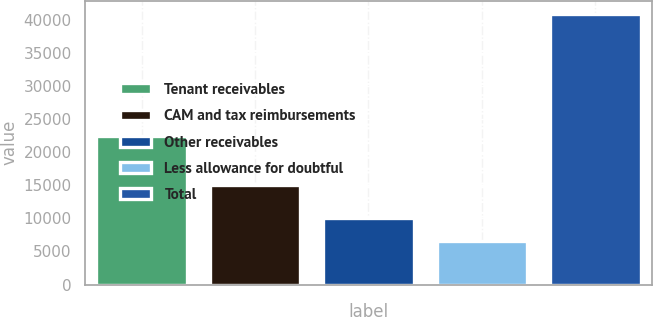<chart> <loc_0><loc_0><loc_500><loc_500><bar_chart><fcel>Tenant receivables<fcel>CAM and tax reimbursements<fcel>Other receivables<fcel>Less allowance for doubtful<fcel>Total<nl><fcel>22395<fcel>15099<fcel>9997.4<fcel>6567<fcel>40871<nl></chart> 